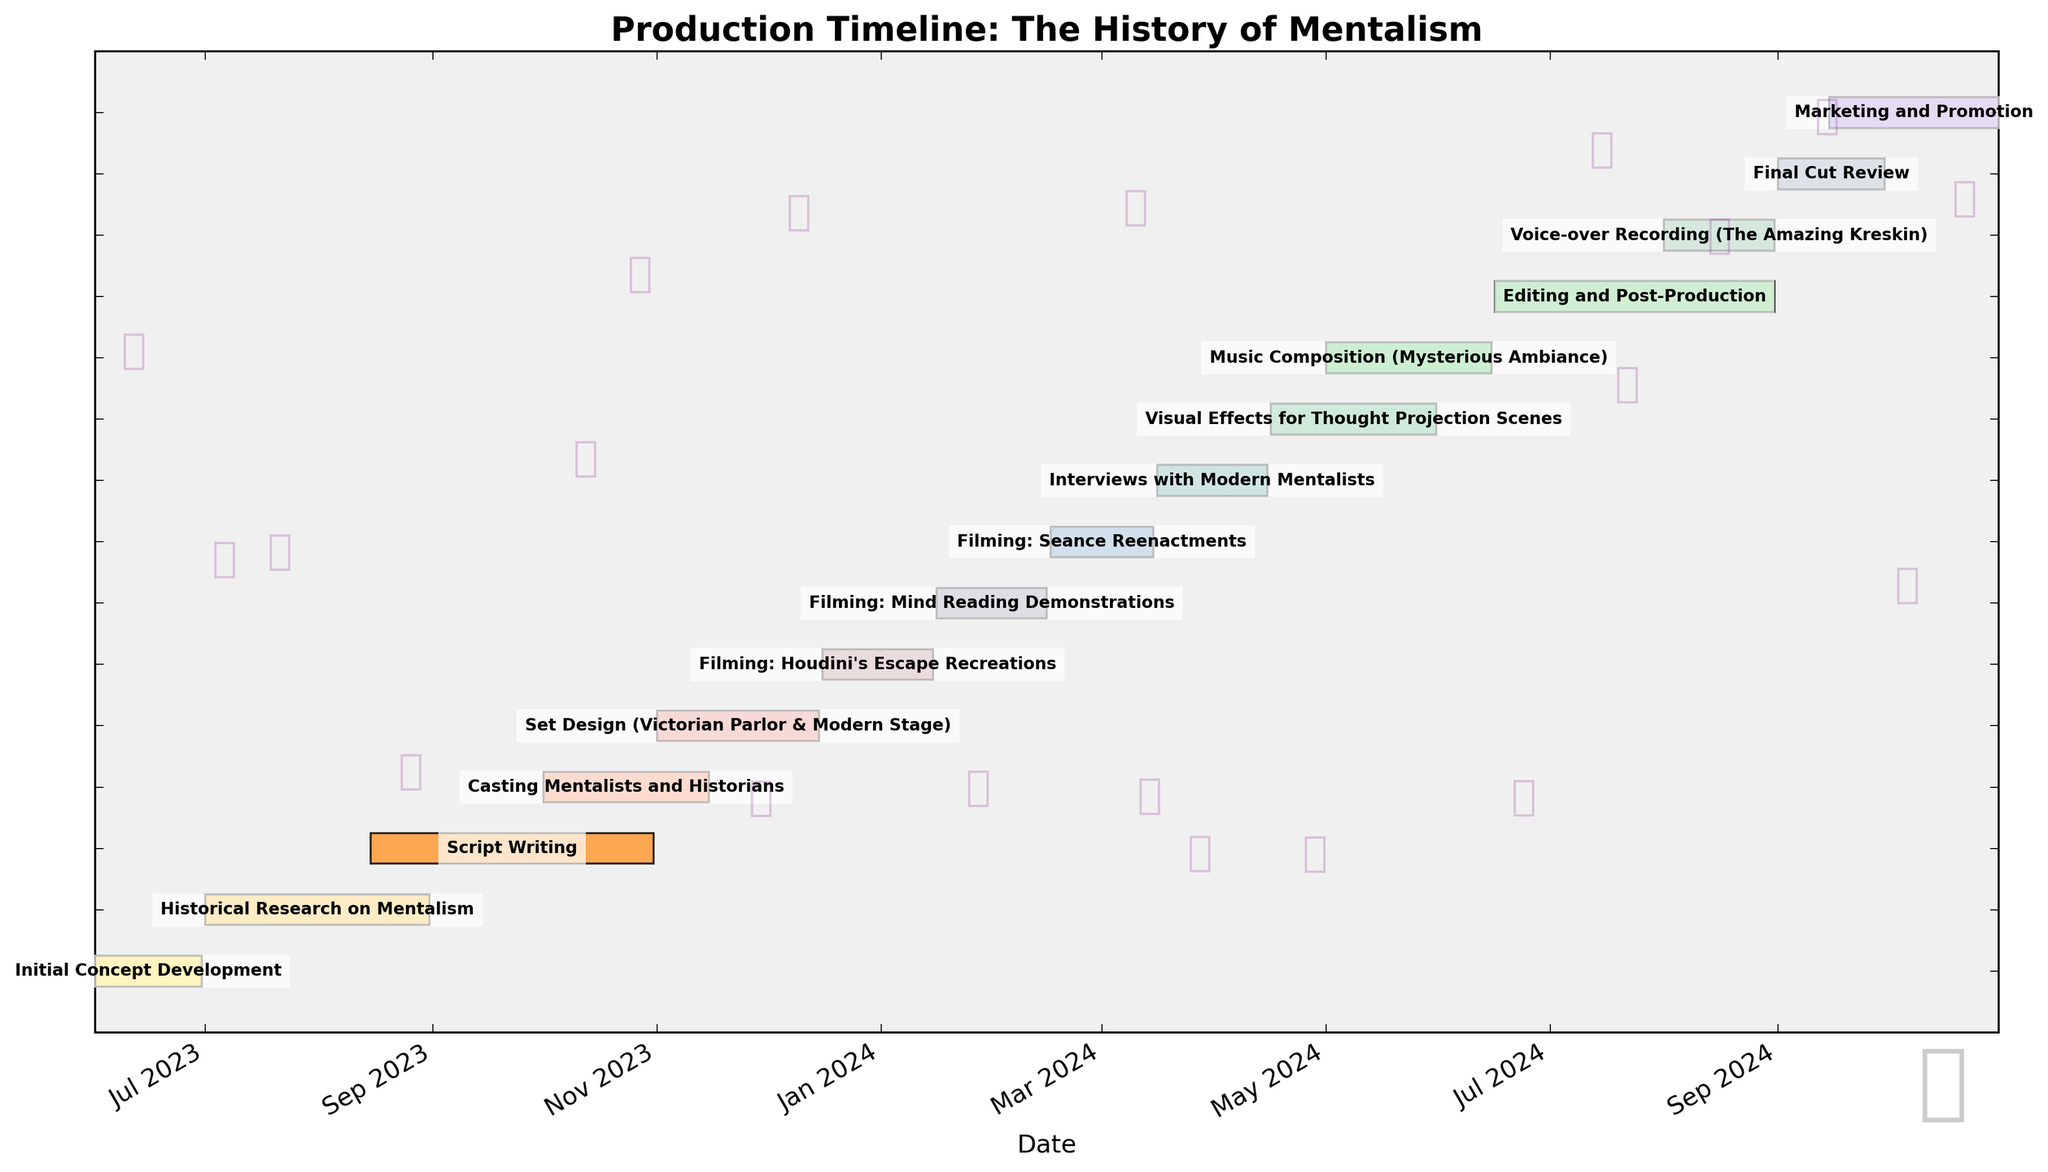What's the title of the Gantt chart? The title is usually found at the top of the chart and is "Production Timeline: The History of Mentalism".
Answer: Production Timeline: The History of Mentalism How many phases in total are represented in the timeline? By counting the bar segments shown on the Gantt chart, we see there are a total of 15 phases listed from the start to the end of the production timeline.
Answer: 15 Which task takes the longest duration to complete? Looking at the horizontal lengths of the bars in the Gantt chart, "Historical Research on Mentalism" spans July to August 2023 which is the longest running task on the chart.
Answer: Historical Research on Mentalism During which months does the "Filming: Seance Reenactments" take place? The bar for "Filming: Seance Reenactments" starts in February 2024 and ends in March 2024, so it occupies these two months.
Answer: February and March 2024 Are there any tasks that overlap with "Editing and Post-Production"? Which ones? By observing the bars, "Editing and Post-Production" from June to August 2024 overlaps with "Voice-over Recording (The Amazing Kreskin)" which happens in August 2024.
Answer: Voice-over Recording (The Amazing Kreskin) What is the duration of the "Final Cut Review" phase? The start and end points of the "Final Cut Review" bar are September 1, 2024, and September 30, 2024, making the duration 30 days.
Answer: 30 days Which phases occur entirely in the year 2023? By checking the start and end dates, the phases "Initial Concept Development," "Historical Research on Mentalism," "Script Writing," "Casting Mentalists and Historians," and "Set Design" all occur completely in 2023.
Answer: Initial Concept Development, Historical Research on Mentalism, Script Writing, Casting Mentalists and Historians, Set Design How many tasks start in the month of March, based on the chart? By looking for start dates specifically marked in March, only "Interviews with Modern Mentalists" starts in March, on the 16th.
Answer: 1 What is the total duration for all the filming phases combined? Adding up individual durations from "Filming: Houdini's Escape Recreations," "Filming: Mind Reading Demonstrations," "Filming: Seance Reenactments," and "Interviews with Modern Mentalists": 30 + 31 + 29 + 31 = 121 days.
Answer: 121 days Which two phases have the shortest duration, and what are they? The shortest bars on the chart correspond to "Casting Mentalists and Historians" (15 days) and "Final Cut Review" (30 days).
Answer: Casting Mentalists and Historians, Final Cut Review 